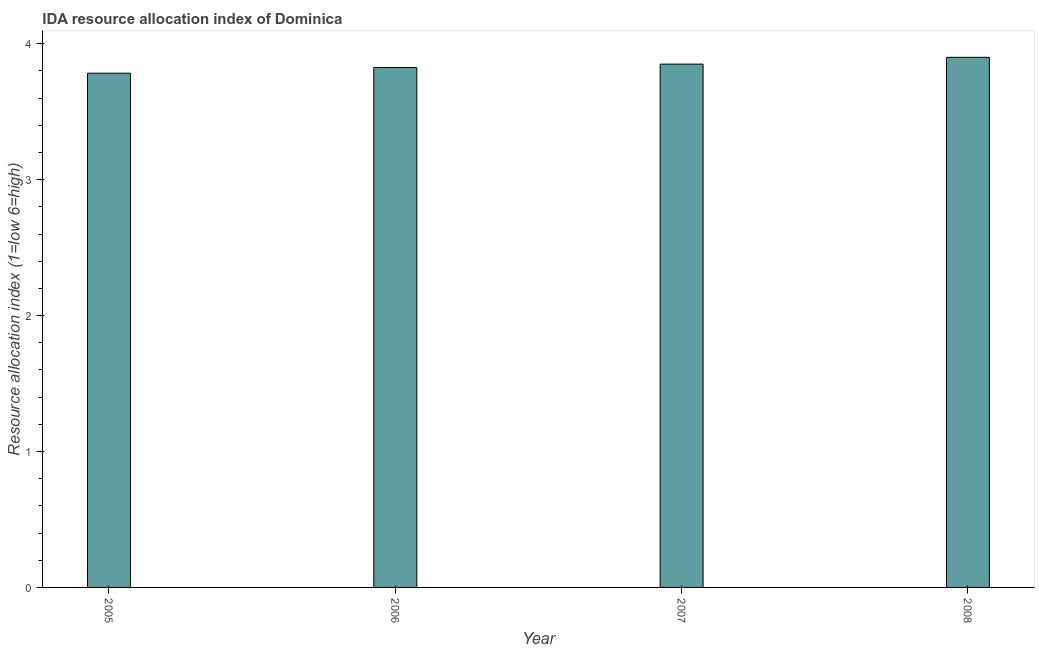Does the graph contain grids?
Keep it short and to the point. No. What is the title of the graph?
Provide a short and direct response. IDA resource allocation index of Dominica. What is the label or title of the Y-axis?
Your response must be concise. Resource allocation index (1=low 6=high). What is the ida resource allocation index in 2005?
Ensure brevity in your answer.  3.78. Across all years, what is the minimum ida resource allocation index?
Keep it short and to the point. 3.78. In which year was the ida resource allocation index minimum?
Your answer should be very brief. 2005. What is the sum of the ida resource allocation index?
Offer a very short reply. 15.36. What is the difference between the ida resource allocation index in 2005 and 2006?
Keep it short and to the point. -0.04. What is the average ida resource allocation index per year?
Your answer should be compact. 3.84. What is the median ida resource allocation index?
Provide a succinct answer. 3.84. Do a majority of the years between 2008 and 2007 (inclusive) have ida resource allocation index greater than 0.6 ?
Offer a terse response. No. What is the difference between the highest and the lowest ida resource allocation index?
Your answer should be compact. 0.12. How many bars are there?
Give a very brief answer. 4. What is the Resource allocation index (1=low 6=high) of 2005?
Offer a very short reply. 3.78. What is the Resource allocation index (1=low 6=high) of 2006?
Give a very brief answer. 3.83. What is the Resource allocation index (1=low 6=high) in 2007?
Give a very brief answer. 3.85. What is the difference between the Resource allocation index (1=low 6=high) in 2005 and 2006?
Offer a very short reply. -0.04. What is the difference between the Resource allocation index (1=low 6=high) in 2005 and 2007?
Ensure brevity in your answer.  -0.07. What is the difference between the Resource allocation index (1=low 6=high) in 2005 and 2008?
Provide a short and direct response. -0.12. What is the difference between the Resource allocation index (1=low 6=high) in 2006 and 2007?
Make the answer very short. -0.03. What is the difference between the Resource allocation index (1=low 6=high) in 2006 and 2008?
Provide a succinct answer. -0.07. What is the ratio of the Resource allocation index (1=low 6=high) in 2005 to that in 2006?
Give a very brief answer. 0.99. What is the ratio of the Resource allocation index (1=low 6=high) in 2006 to that in 2007?
Keep it short and to the point. 0.99. What is the ratio of the Resource allocation index (1=low 6=high) in 2007 to that in 2008?
Make the answer very short. 0.99. 